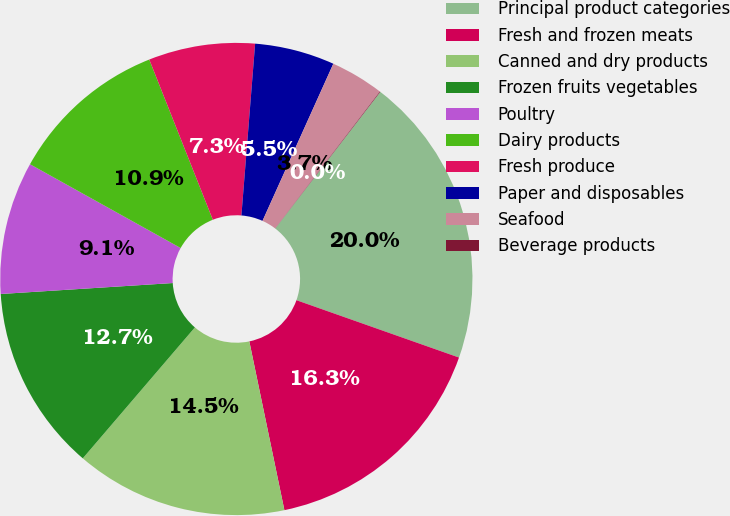<chart> <loc_0><loc_0><loc_500><loc_500><pie_chart><fcel>Principal product categories<fcel>Fresh and frozen meats<fcel>Canned and dry products<fcel>Frozen fruits vegetables<fcel>Poultry<fcel>Dairy products<fcel>Fresh produce<fcel>Paper and disposables<fcel>Seafood<fcel>Beverage products<nl><fcel>19.96%<fcel>16.34%<fcel>14.53%<fcel>12.72%<fcel>9.09%<fcel>10.91%<fcel>7.28%<fcel>5.47%<fcel>3.66%<fcel>0.04%<nl></chart> 